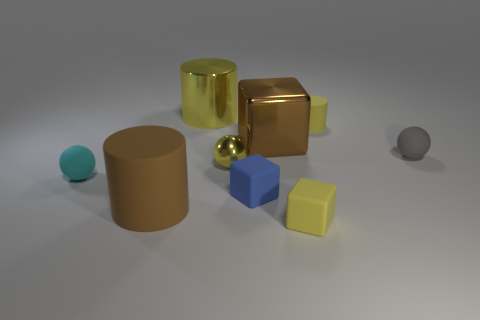Subtract all blue blocks. How many blocks are left? 2 Subtract 1 cylinders. How many cylinders are left? 2 Subtract all cubes. How many objects are left? 6 Subtract 0 cyan blocks. How many objects are left? 9 Subtract all tiny purple balls. Subtract all rubber cylinders. How many objects are left? 7 Add 8 small blue blocks. How many small blue blocks are left? 9 Add 3 small gray blocks. How many small gray blocks exist? 3 